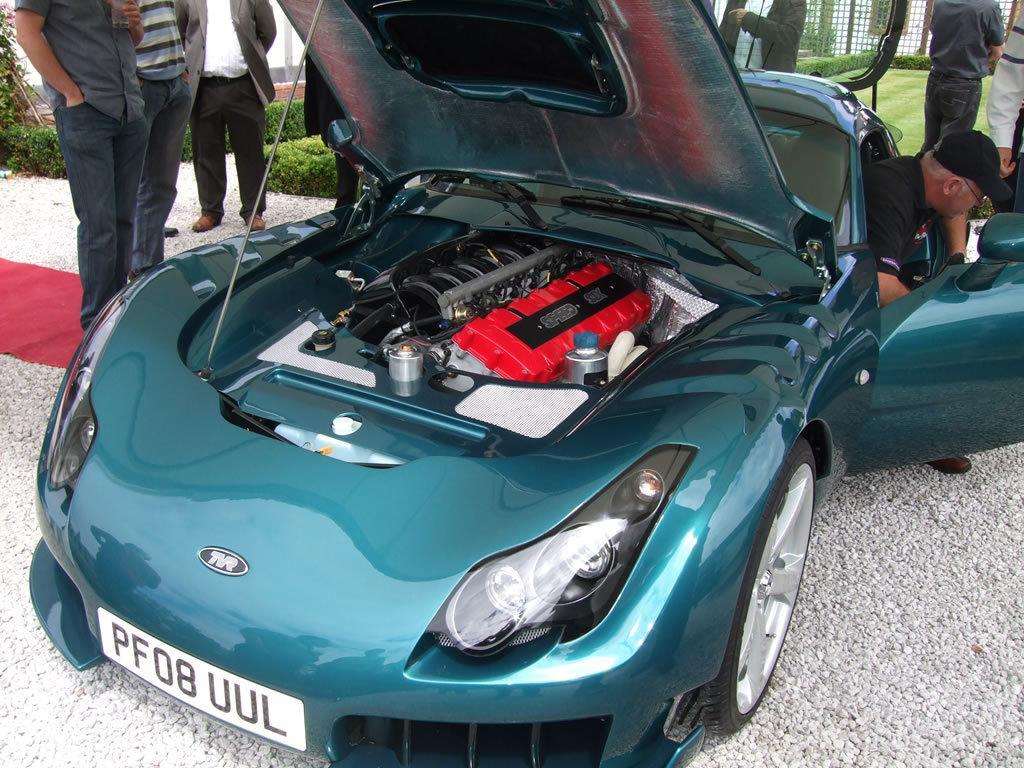Please provide a concise description of this image. In this picture we can see a green color car and some people around the car. 